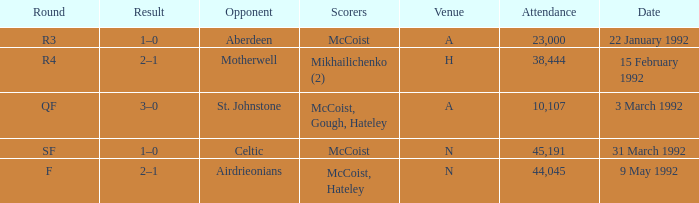In which venue was round F? N. 